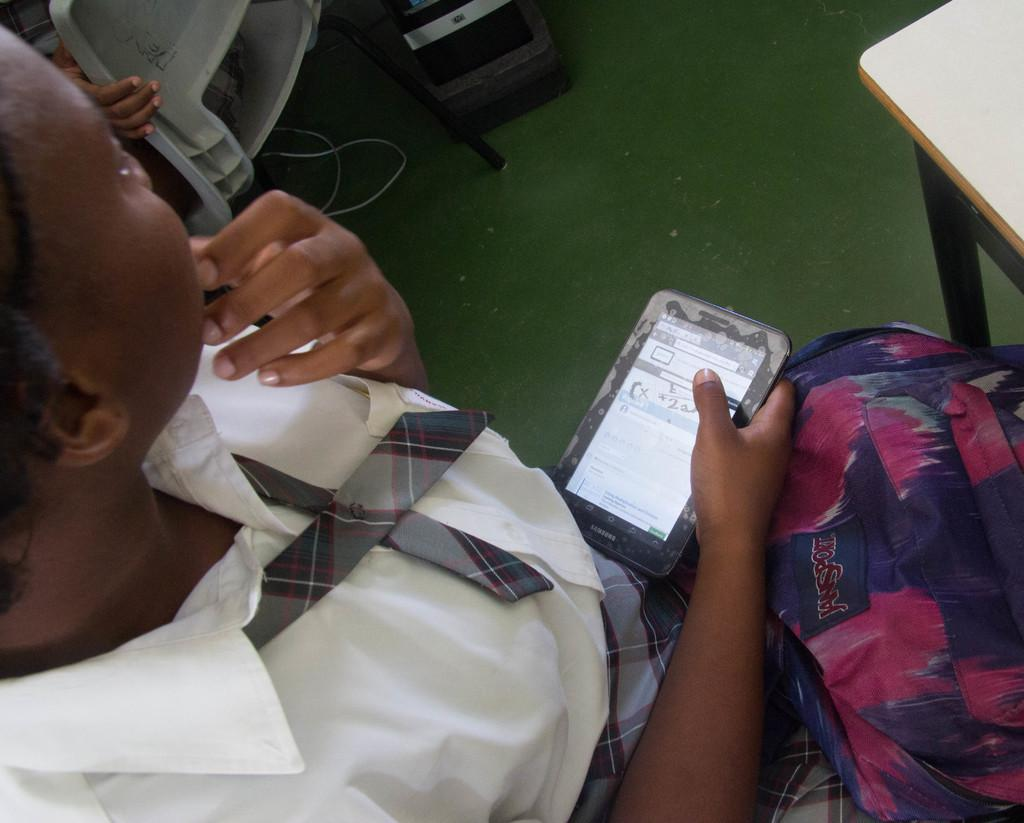What is the man in the image holding in his hand? The man is holding a mobile in his hand. What else is the man holding in the image? The man is also holding a bag. Is there a volcano erupting in the background of the image? There is no volcano present in the image. How does the man plan to increase his wealth using the mobile and the bag? The image does not provide any information about the man's intentions or plans, so it cannot be determined from the image. 